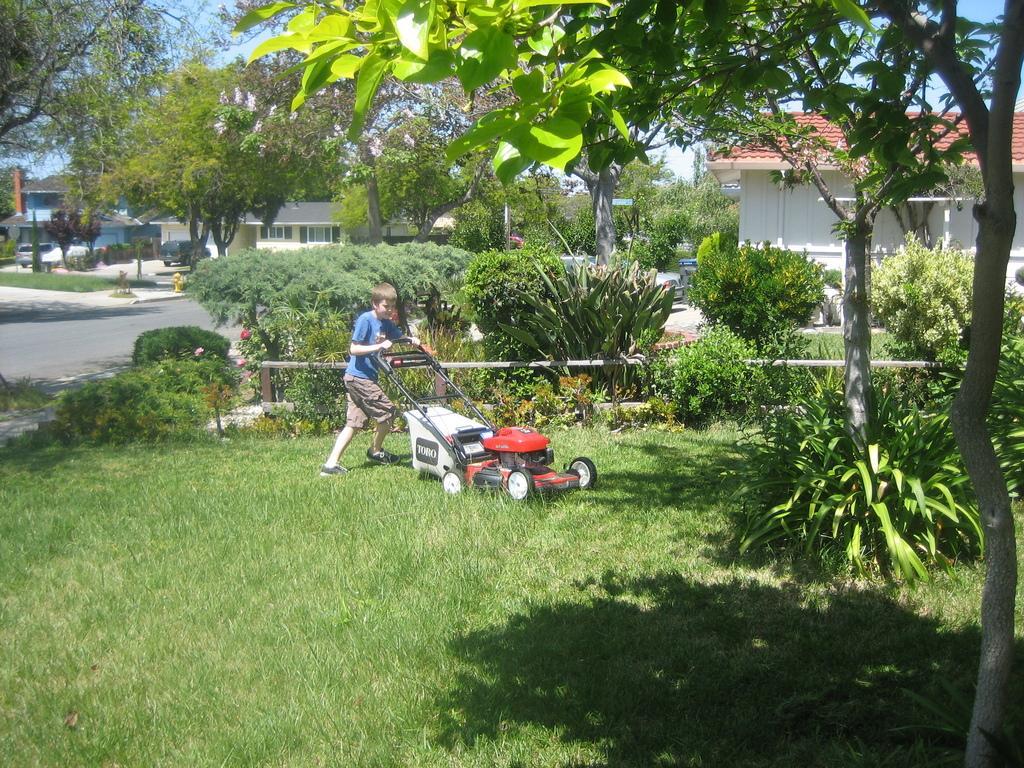In one or two sentences, can you explain what this image depicts? In this image we can see a boy is holding a machine with his which cuts the grass. In the background there are trees, road, vehicles, houses, plants and sky. 